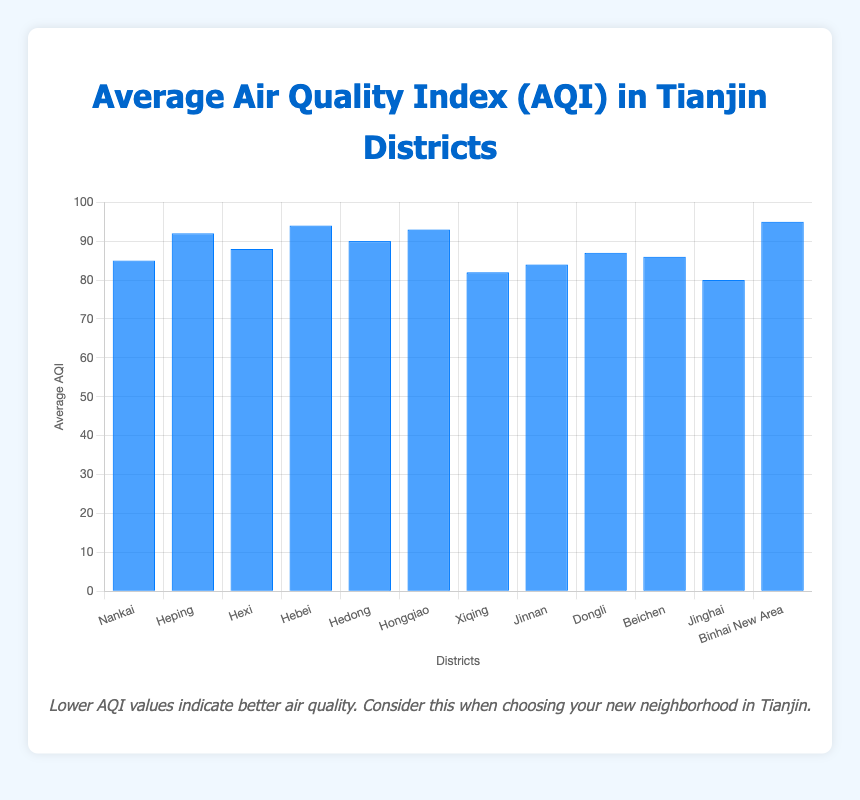Which district has the highest average AQI? By observing the height of the bars, the district with the highest bar corresponds to the highest average AQI. Binhai New Area has the highest bar.
Answer: Binhai New Area Which district has the lowest average AQI? By looking for the shortest bar, we can identify the district with the lowest average AQI. Jinghai District has the shortest bar.
Answer: Jinghai District Compare the AQIs of Heping District and Hebei District; which has a higher value? Check the height of the bars for both districts. The bar for Hebei District is slightly higher than the bar for Heping District.
Answer: Hebei District What is the average AQI of the top three districts with the highest AQI? The top three districts by AQI are Binhai New Area (95), Hebei District (94), and Hongqiao District (93). Calculate the average: (95 + 94 + 93) / 3.
Answer: 94 How much higher is the AQI in Binhai New Area compared to Jinghai District? Subtract the AQI of Jinghai District from the AQI of Binhai New Area: 95 - 80.
Answer: 15 Identify the districts with an AQI greater than 90. Look for bars exceeding the 90 mark. These are Heping District (92), Hebei District (94), Hedong District (90), Hongqiao District (93), and Binhai New Area (95).
Answer: Heping, Hebei, Hedong, Hongqiao, Binhai New Area Is the average AQI of Nankai District higher or lower than that of Beichen District? Compare the heights of the bars for Nankai District (85) and Beichen District (86). Nankai's bar is slightly lower.
Answer: Lower Which districts have an AQI value between 85 and 90? Identify the bars positioned between the 85 and 90 marks. These are Hexi District (88), Hedong District (90), Dongli District (87), and Beichen District (86).
Answer: Hexi, Hedong, Dongli, Beichen Calculate the difference between the AQI values of Xiqing District and Hongqiao District. Subtract the AQI of Xiqing District (82) from the AQI of Hongqiao District (93): 93 - 82.
Answer: 11 What is the total AQI of Nankai District, Xiqing District, and Jinnan District combined? Add the AQI values: 85 (Nankai) + 82 (Xiqing) + 84 (Jinnan).
Answer: 251 